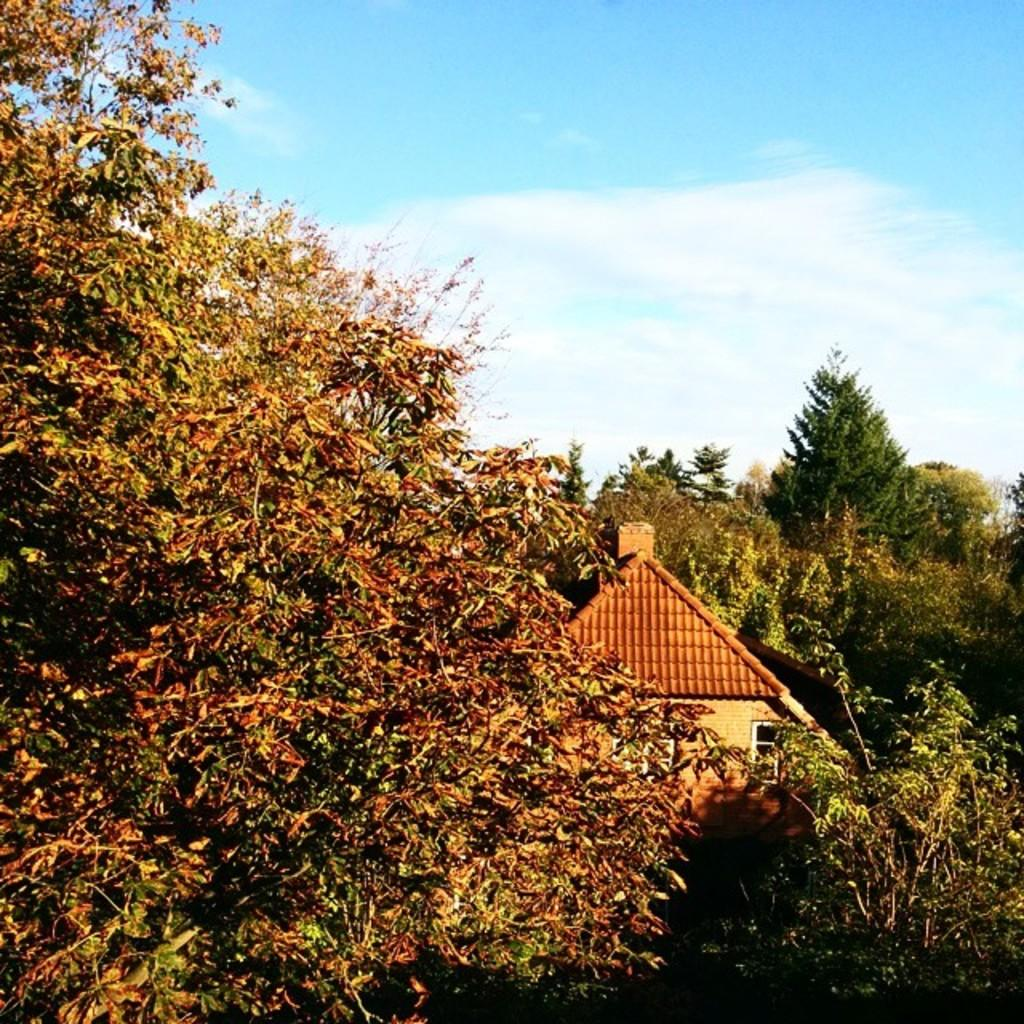What type of vegetation can be seen in the image? There are trees in the image. What type of structure is visible in the image? There is a house in the image. What is visible in the background of the image? The sky is visible in the background of the image. What can be observed in the sky? Clouds are present in the sky. What role does the porter play in the image? There is no porter present in the image. What act is being performed by the trees in the image? Trees are not performing any act; they are stationary vegetation. 